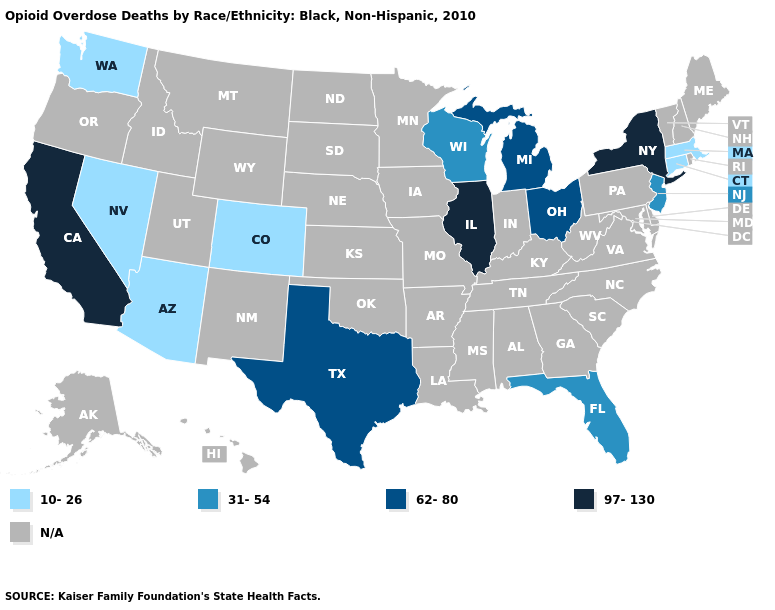Which states have the highest value in the USA?
Short answer required. California, Illinois, New York. Name the states that have a value in the range 62-80?
Keep it brief. Michigan, Ohio, Texas. Name the states that have a value in the range 31-54?
Answer briefly. Florida, New Jersey, Wisconsin. What is the lowest value in the Northeast?
Write a very short answer. 10-26. Does the map have missing data?
Short answer required. Yes. Among the states that border Oregon , which have the lowest value?
Concise answer only. Nevada, Washington. Does the first symbol in the legend represent the smallest category?
Concise answer only. Yes. What is the value of Pennsylvania?
Quick response, please. N/A. Which states have the lowest value in the West?
Short answer required. Arizona, Colorado, Nevada, Washington. Name the states that have a value in the range 10-26?
Be succinct. Arizona, Colorado, Connecticut, Massachusetts, Nevada, Washington. Which states have the lowest value in the USA?
Keep it brief. Arizona, Colorado, Connecticut, Massachusetts, Nevada, Washington. What is the value of California?
Concise answer only. 97-130. What is the value of New York?
Be succinct. 97-130. Which states have the lowest value in the Northeast?
Answer briefly. Connecticut, Massachusetts. 